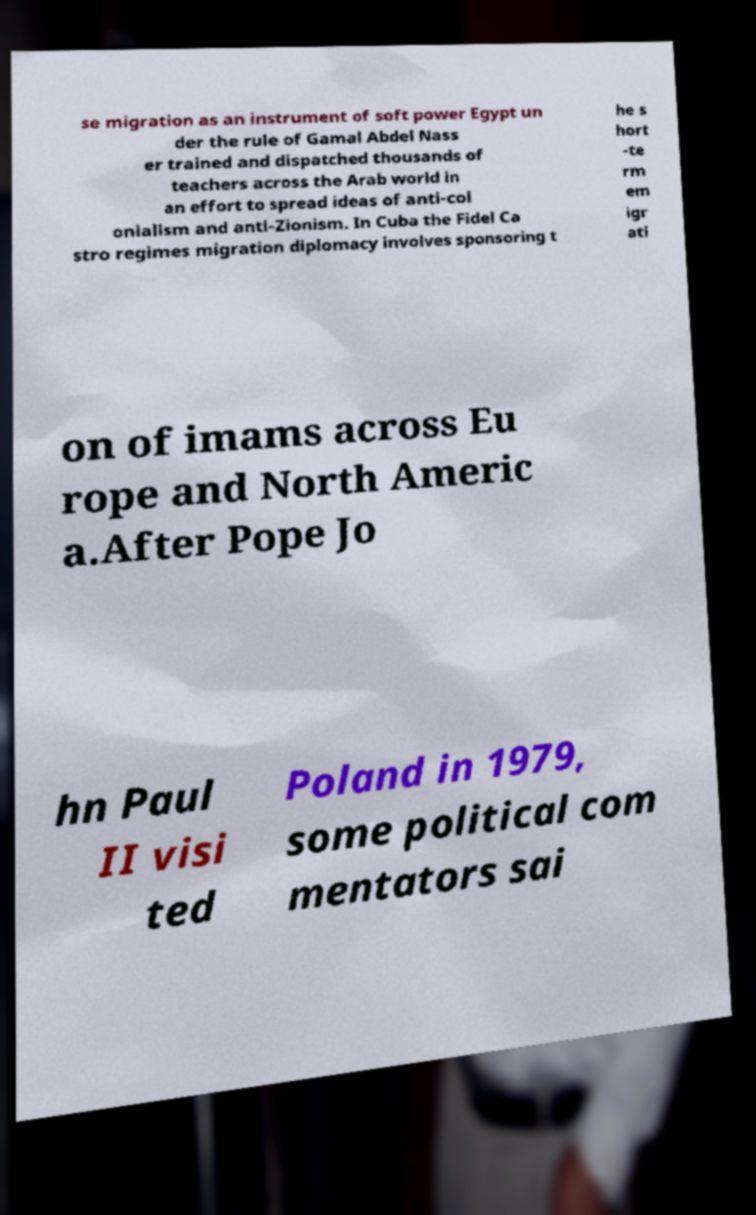Please read and relay the text visible in this image. What does it say? se migration as an instrument of soft power Egypt un der the rule of Gamal Abdel Nass er trained and dispatched thousands of teachers across the Arab world in an effort to spread ideas of anti-col onialism and anti-Zionism. In Cuba the Fidel Ca stro regimes migration diplomacy involves sponsoring t he s hort -te rm em igr ati on of imams across Eu rope and North Americ a.After Pope Jo hn Paul II visi ted Poland in 1979, some political com mentators sai 